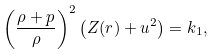<formula> <loc_0><loc_0><loc_500><loc_500>\left ( \frac { \rho + p } { \rho } \right ) ^ { 2 } \left ( Z ( r ) + u ^ { 2 } \right ) = k _ { 1 } ,</formula> 